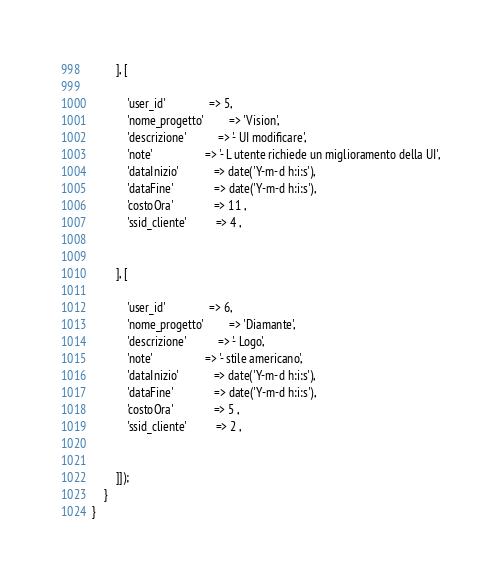Convert code to text. <code><loc_0><loc_0><loc_500><loc_500><_PHP_>		], [

	        'user_id' 		        => 5,
	        'nome_progetto' 		=> 'Vision',
	        'descrizione' 		    => '- UI modificare',
	        'note' 		            => '- L utente richiede un miglioramento della UI',
	        'dataInizio' 		    => date('Y-m-d h:i:s'),
	        'dataFine' 		        => date('Y-m-d h:i:s'),
	        'costoOra' 	            => 11 ,
			'ssid_cliente'		    => 4 ,

		
		], [

	        'user_id' 		        => 6,
	        'nome_progetto' 		=> 'Diamante',
	        'descrizione' 		    => '- Logo',
	        'note' 		            => '- stile americano',
	        'dataInizio' 		    => date('Y-m-d h:i:s'),
	        'dataFine' 		        => date('Y-m-d h:i:s'),
	        'costoOra' 	            => 5 ,
			'ssid_cliente'		    => 2 ,

		
		]]);
    }
}
</code> 